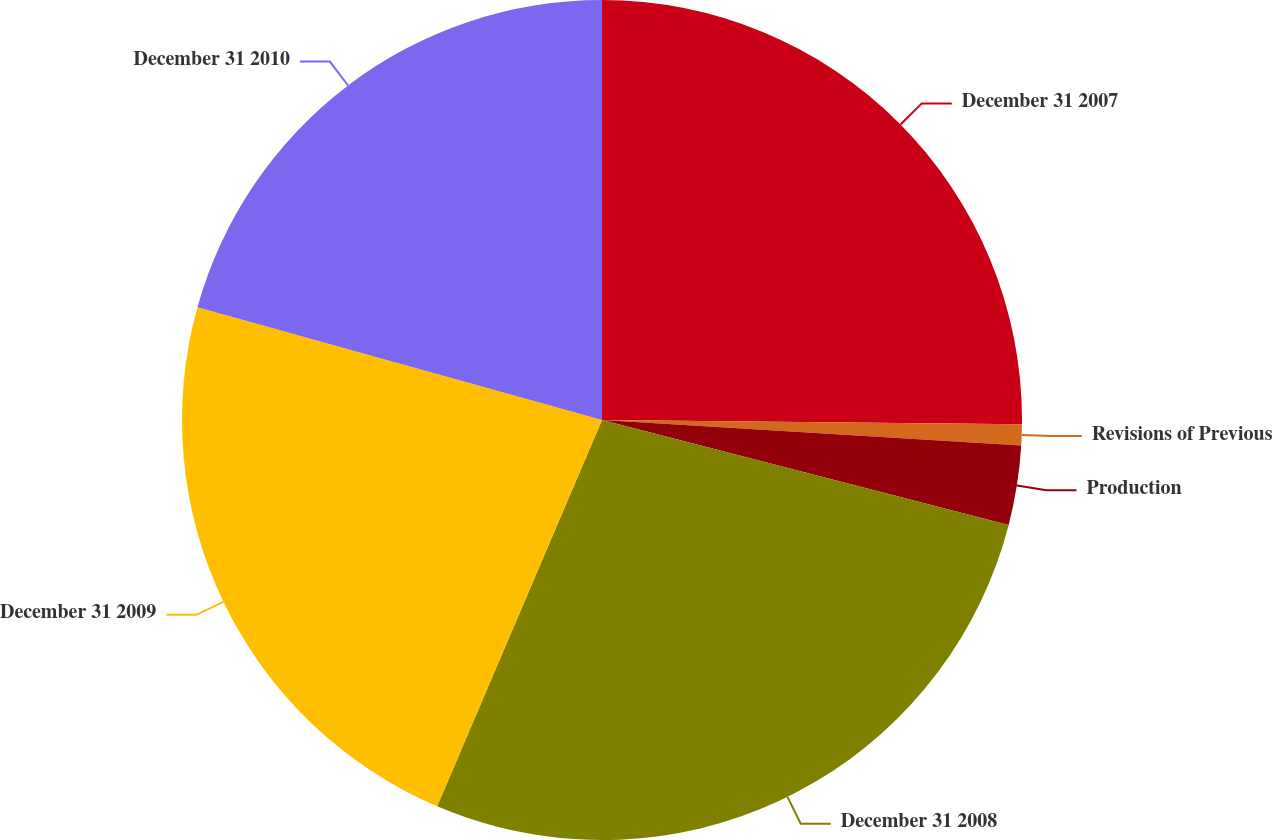Convert chart to OTSL. <chart><loc_0><loc_0><loc_500><loc_500><pie_chart><fcel>December 31 2007<fcel>Revisions of Previous<fcel>Production<fcel>December 31 2008<fcel>December 31 2009<fcel>December 31 2010<nl><fcel>25.16%<fcel>0.81%<fcel>3.05%<fcel>27.4%<fcel>22.91%<fcel>20.67%<nl></chart> 